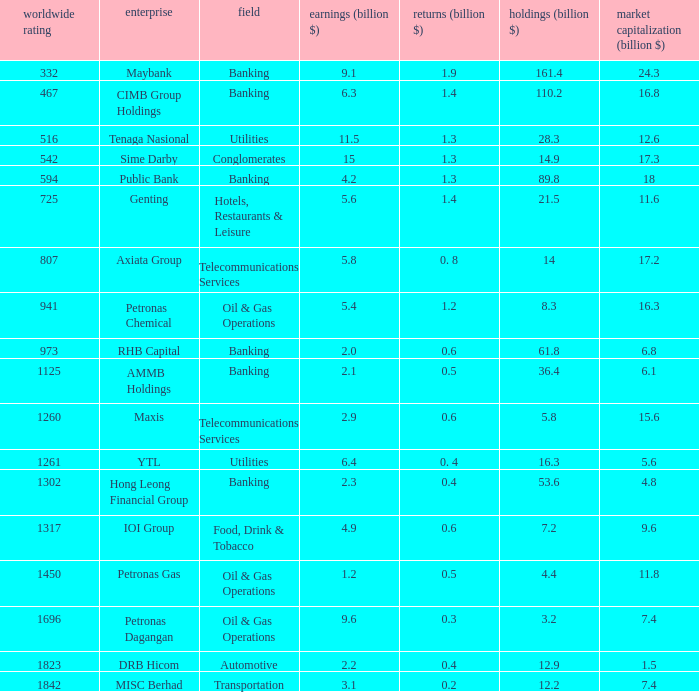Name the industry for revenue being 2.1 Banking. 